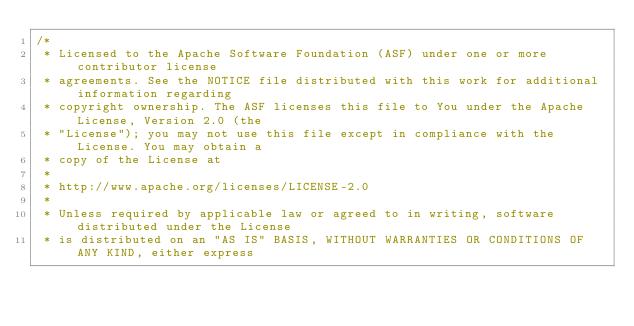Convert code to text. <code><loc_0><loc_0><loc_500><loc_500><_Java_>/*
 * Licensed to the Apache Software Foundation (ASF) under one or more contributor license
 * agreements. See the NOTICE file distributed with this work for additional information regarding
 * copyright ownership. The ASF licenses this file to You under the Apache License, Version 2.0 (the
 * "License"); you may not use this file except in compliance with the License. You may obtain a
 * copy of the License at
 *
 * http://www.apache.org/licenses/LICENSE-2.0
 *
 * Unless required by applicable law or agreed to in writing, software distributed under the License
 * is distributed on an "AS IS" BASIS, WITHOUT WARRANTIES OR CONDITIONS OF ANY KIND, either express</code> 